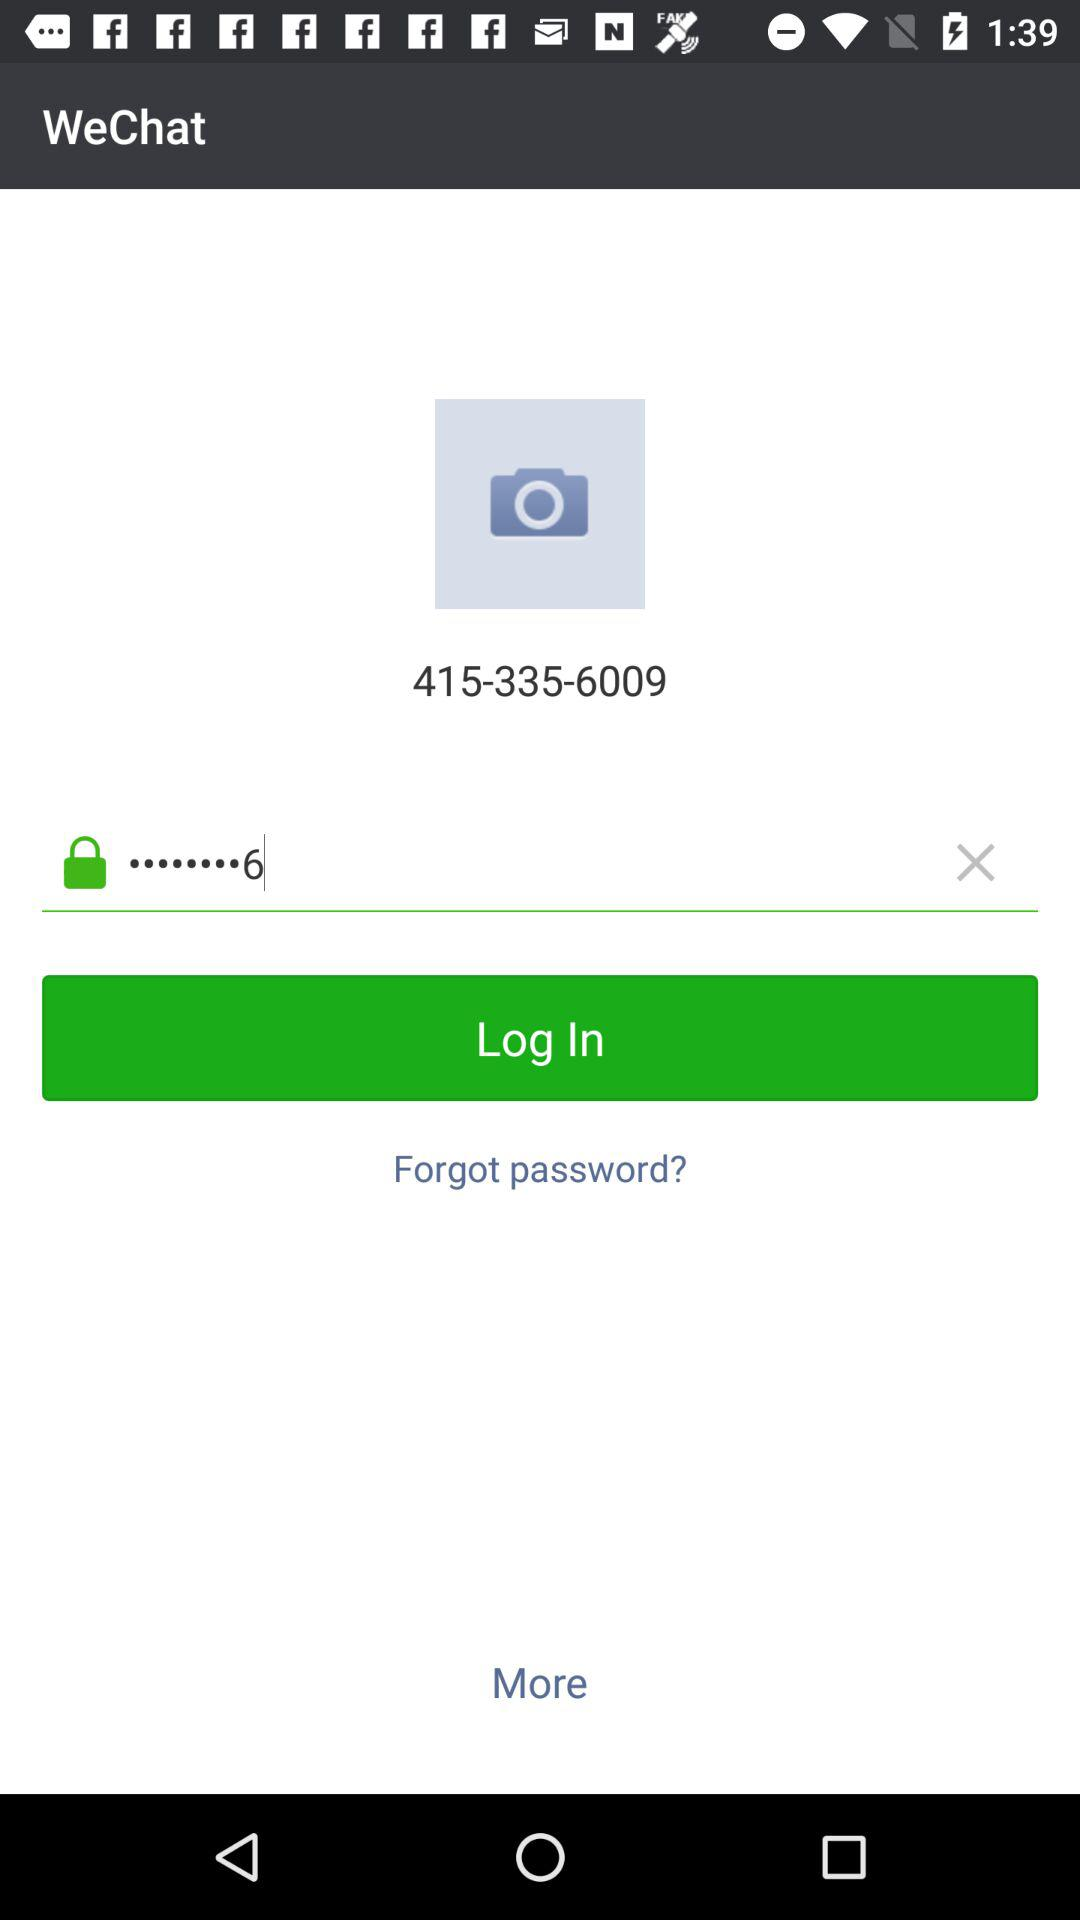What is the application name? The application name is "WeChat". 